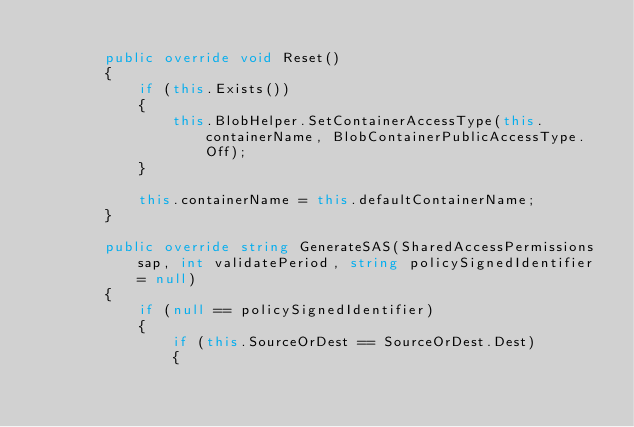<code> <loc_0><loc_0><loc_500><loc_500><_C#_>
        public override void Reset()
        {
            if (this.Exists())
            {
                this.BlobHelper.SetContainerAccessType(this.containerName, BlobContainerPublicAccessType.Off);
            }

            this.containerName = this.defaultContainerName;
        }

        public override string GenerateSAS(SharedAccessPermissions sap, int validatePeriod, string policySignedIdentifier = null)
        {
            if (null == policySignedIdentifier)
            {
                if (this.SourceOrDest == SourceOrDest.Dest)
                {</code> 